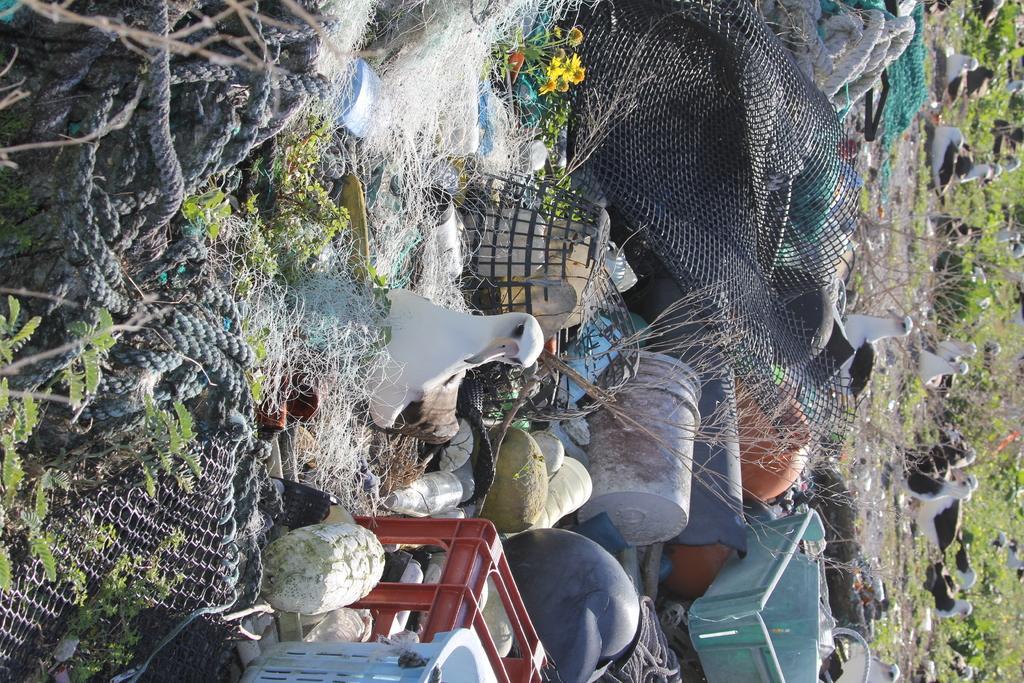Please provide a concise description of this image. On the left side of the image we can see a rope and iron net. In the middle of the image we can see a bird, net and boxes. On the right side of the image we can see birds, mud and grass. 